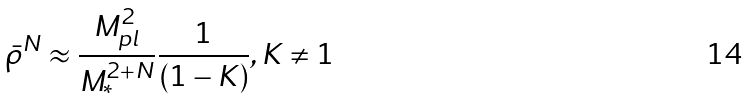<formula> <loc_0><loc_0><loc_500><loc_500>\bar { \rho } ^ { N } \approx \frac { M _ { p l } ^ { 2 } } { M _ { \ast } ^ { 2 + N } } \frac { 1 } { ( 1 - K ) } , K \neq 1</formula> 